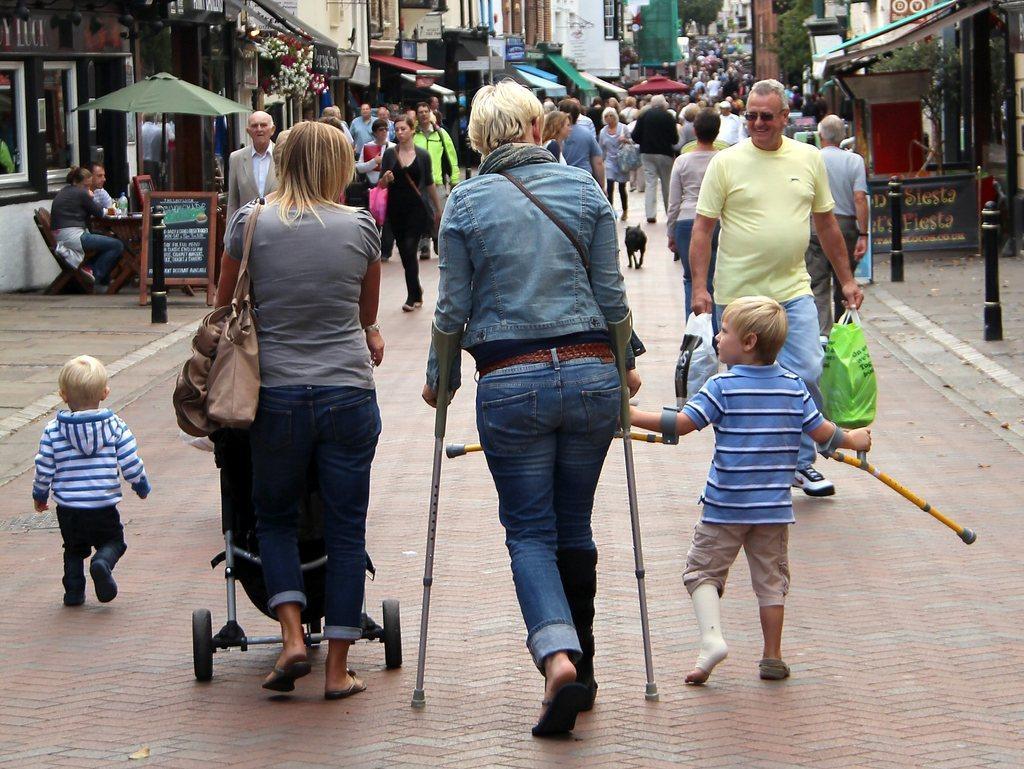In one or two sentences, can you explain what this image depicts? In this image I can see number of people are walking. In the front I can see one woman is holding a stroller and another one is holding two sticks. On the right side of this image I can see a boy is holding two sticks. In the background I can see number of buildings, few trees, few boards and on these boards I can see something is written. On the right side of this image I can see one man is holding two carry bags. 